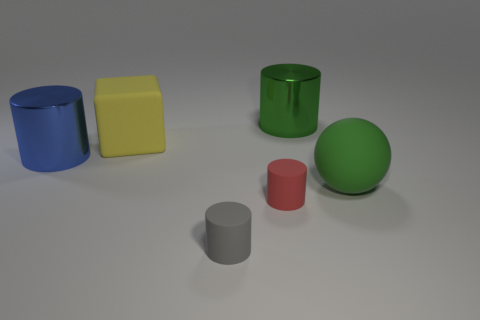There is another shiny thing that is the same shape as the big blue thing; what is its size?
Provide a short and direct response. Large. What number of other objects are there of the same size as the blue shiny thing?
Give a very brief answer. 3. What shape is the large matte object that is left of the green object that is on the right side of the metallic cylinder behind the big blue shiny cylinder?
Offer a terse response. Cube. There is a block; is it the same size as the red thing on the left side of the green rubber sphere?
Ensure brevity in your answer.  No. There is a big thing that is both right of the rubber block and in front of the green metallic object; what is its color?
Your response must be concise. Green. How many other things are the same shape as the blue object?
Ensure brevity in your answer.  3. Does the shiny cylinder that is right of the red cylinder have the same color as the big rubber thing right of the green shiny object?
Offer a very short reply. Yes. Is the size of the yellow rubber thing on the left side of the gray matte object the same as the object that is in front of the red matte object?
Offer a terse response. No. There is a blue object that is left of the big shiny cylinder right of the big cylinder that is in front of the large green cylinder; what is it made of?
Your answer should be compact. Metal. Does the small gray matte object have the same shape as the blue thing?
Give a very brief answer. Yes. 